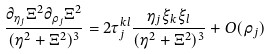<formula> <loc_0><loc_0><loc_500><loc_500>\frac { \partial _ { \eta _ { j } } \Xi ^ { 2 } \partial _ { \rho _ { j } } \Xi ^ { 2 } } { ( \eta ^ { 2 } + \Xi ^ { 2 } ) ^ { 3 } } = 2 \tau _ { j } ^ { k l } \frac { \eta _ { j } \xi _ { k } \xi _ { l } } { ( \eta ^ { 2 } + \Xi ^ { 2 } ) ^ { 3 } } + O ( \rho _ { j } )</formula> 